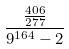<formula> <loc_0><loc_0><loc_500><loc_500>\frac { \frac { 4 0 6 } { 2 7 7 } } { 9 ^ { 1 6 4 } - 2 }</formula> 